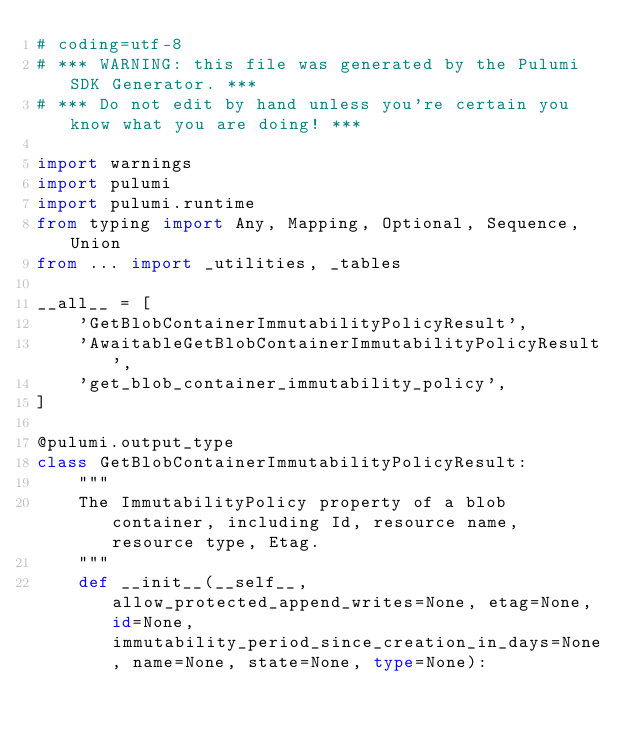Convert code to text. <code><loc_0><loc_0><loc_500><loc_500><_Python_># coding=utf-8
# *** WARNING: this file was generated by the Pulumi SDK Generator. ***
# *** Do not edit by hand unless you're certain you know what you are doing! ***

import warnings
import pulumi
import pulumi.runtime
from typing import Any, Mapping, Optional, Sequence, Union
from ... import _utilities, _tables

__all__ = [
    'GetBlobContainerImmutabilityPolicyResult',
    'AwaitableGetBlobContainerImmutabilityPolicyResult',
    'get_blob_container_immutability_policy',
]

@pulumi.output_type
class GetBlobContainerImmutabilityPolicyResult:
    """
    The ImmutabilityPolicy property of a blob container, including Id, resource name, resource type, Etag.
    """
    def __init__(__self__, allow_protected_append_writes=None, etag=None, id=None, immutability_period_since_creation_in_days=None, name=None, state=None, type=None):</code> 